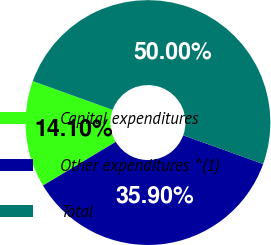<chart> <loc_0><loc_0><loc_500><loc_500><pie_chart><fcel>Capital expenditures<fcel>Other expenditures ^(1)<fcel>Total<nl><fcel>14.1%<fcel>35.9%<fcel>50.0%<nl></chart> 